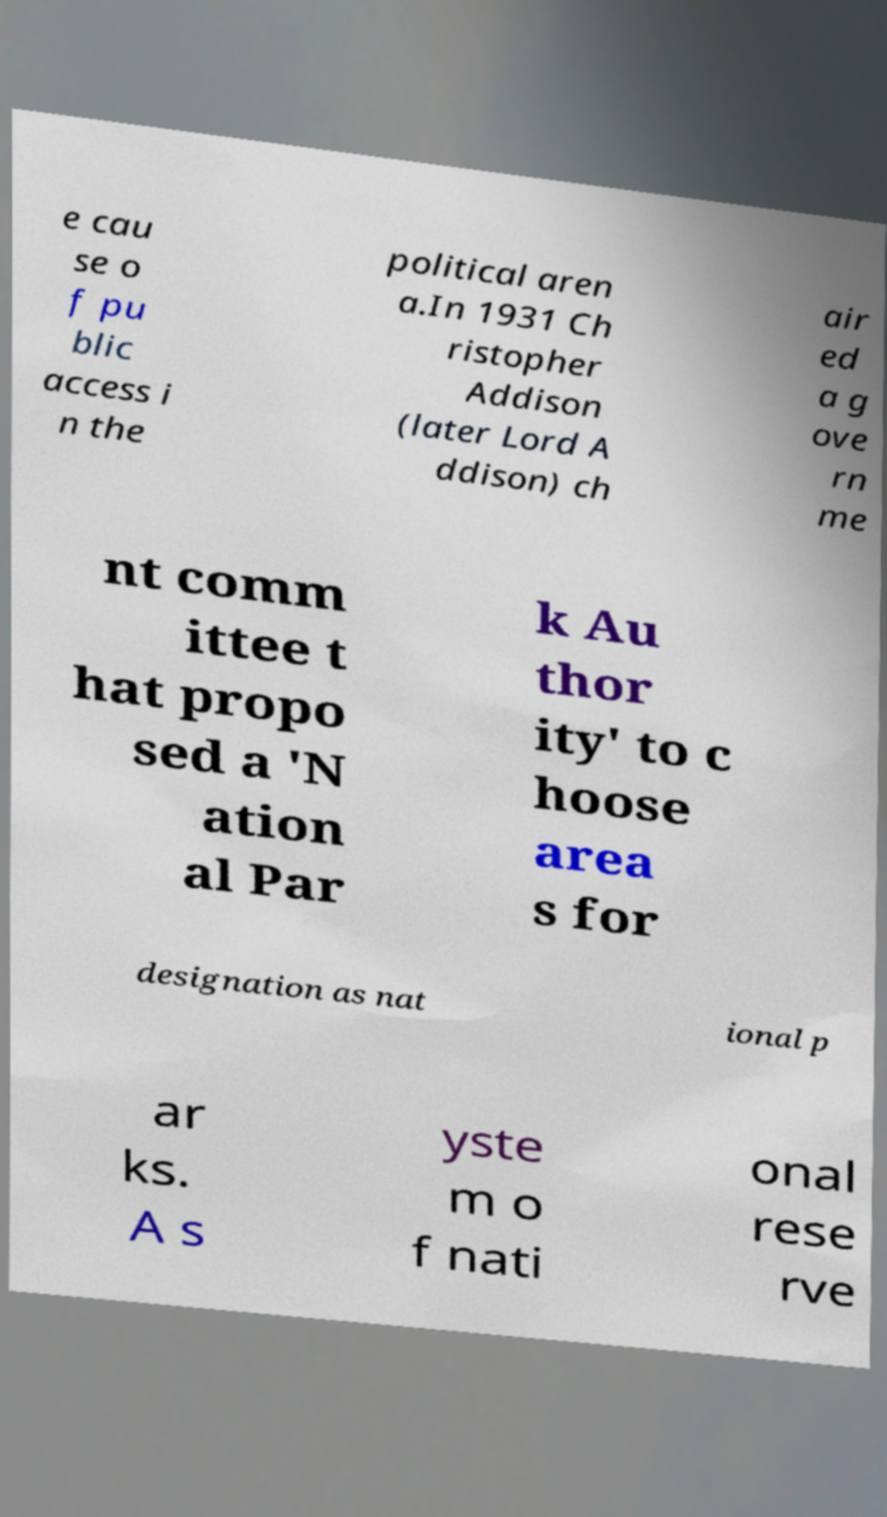I need the written content from this picture converted into text. Can you do that? e cau se o f pu blic access i n the political aren a.In 1931 Ch ristopher Addison (later Lord A ddison) ch air ed a g ove rn me nt comm ittee t hat propo sed a 'N ation al Par k Au thor ity' to c hoose area s for designation as nat ional p ar ks. A s yste m o f nati onal rese rve 